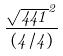<formula> <loc_0><loc_0><loc_500><loc_500>\frac { \sqrt { 4 4 1 } ^ { 2 } } { ( 4 / 4 ) }</formula> 